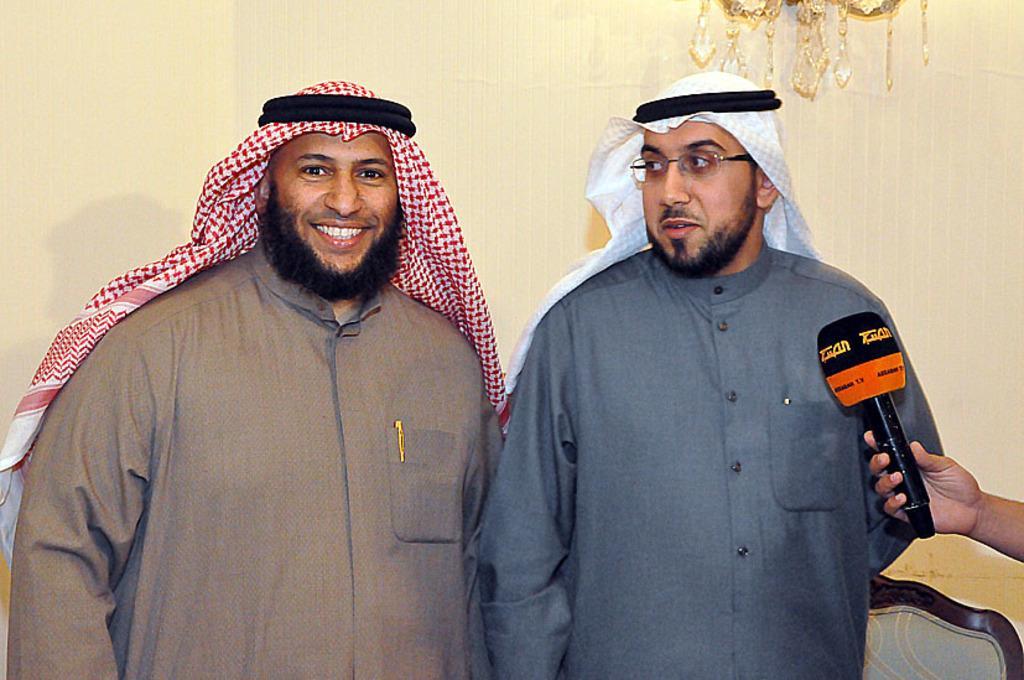In one or two sentences, can you explain what this image depicts? In this image I can see 2 men standing. A person is holding a microphone on the right. There is a wall at the back and chandelier at the top. 